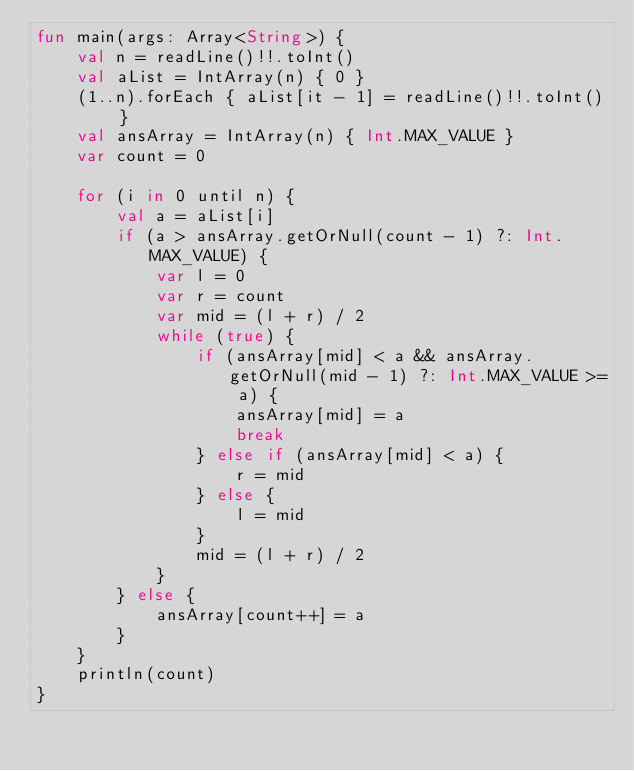Convert code to text. <code><loc_0><loc_0><loc_500><loc_500><_Kotlin_>fun main(args: Array<String>) {
    val n = readLine()!!.toInt()
    val aList = IntArray(n) { 0 }
    (1..n).forEach { aList[it - 1] = readLine()!!.toInt() }
    val ansArray = IntArray(n) { Int.MAX_VALUE }
    var count = 0

    for (i in 0 until n) {
        val a = aList[i]
        if (a > ansArray.getOrNull(count - 1) ?: Int.MAX_VALUE) {
            var l = 0
            var r = count
            var mid = (l + r) / 2
            while (true) {
                if (ansArray[mid] < a && ansArray.getOrNull(mid - 1) ?: Int.MAX_VALUE >= a) {
                    ansArray[mid] = a
                    break
                } else if (ansArray[mid] < a) {
                    r = mid
                } else {
                    l = mid
                }
                mid = (l + r) / 2
            }
        } else {
            ansArray[count++] = a
        }
    }
    println(count)
}</code> 